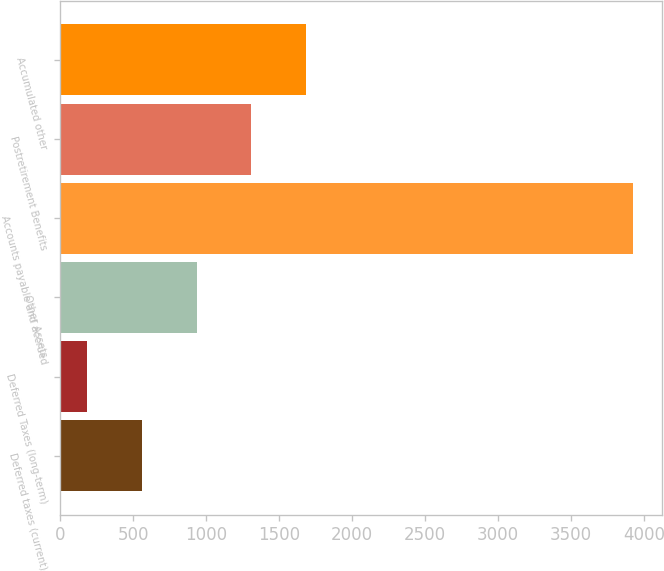Convert chart. <chart><loc_0><loc_0><loc_500><loc_500><bar_chart><fcel>Deferred taxes (current)<fcel>Deferred Taxes (long-term)<fcel>Other Assets<fcel>Accounts payable and accrued<fcel>Postretirement Benefits<fcel>Accumulated other<nl><fcel>559.9<fcel>186<fcel>933.8<fcel>3925<fcel>1307.7<fcel>1681.6<nl></chart> 